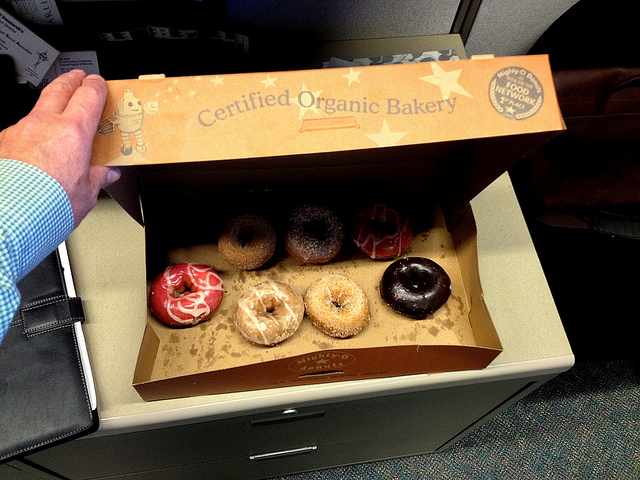Identify the text contained in this image. Certified Organic Bakery FOOD NETWORK 